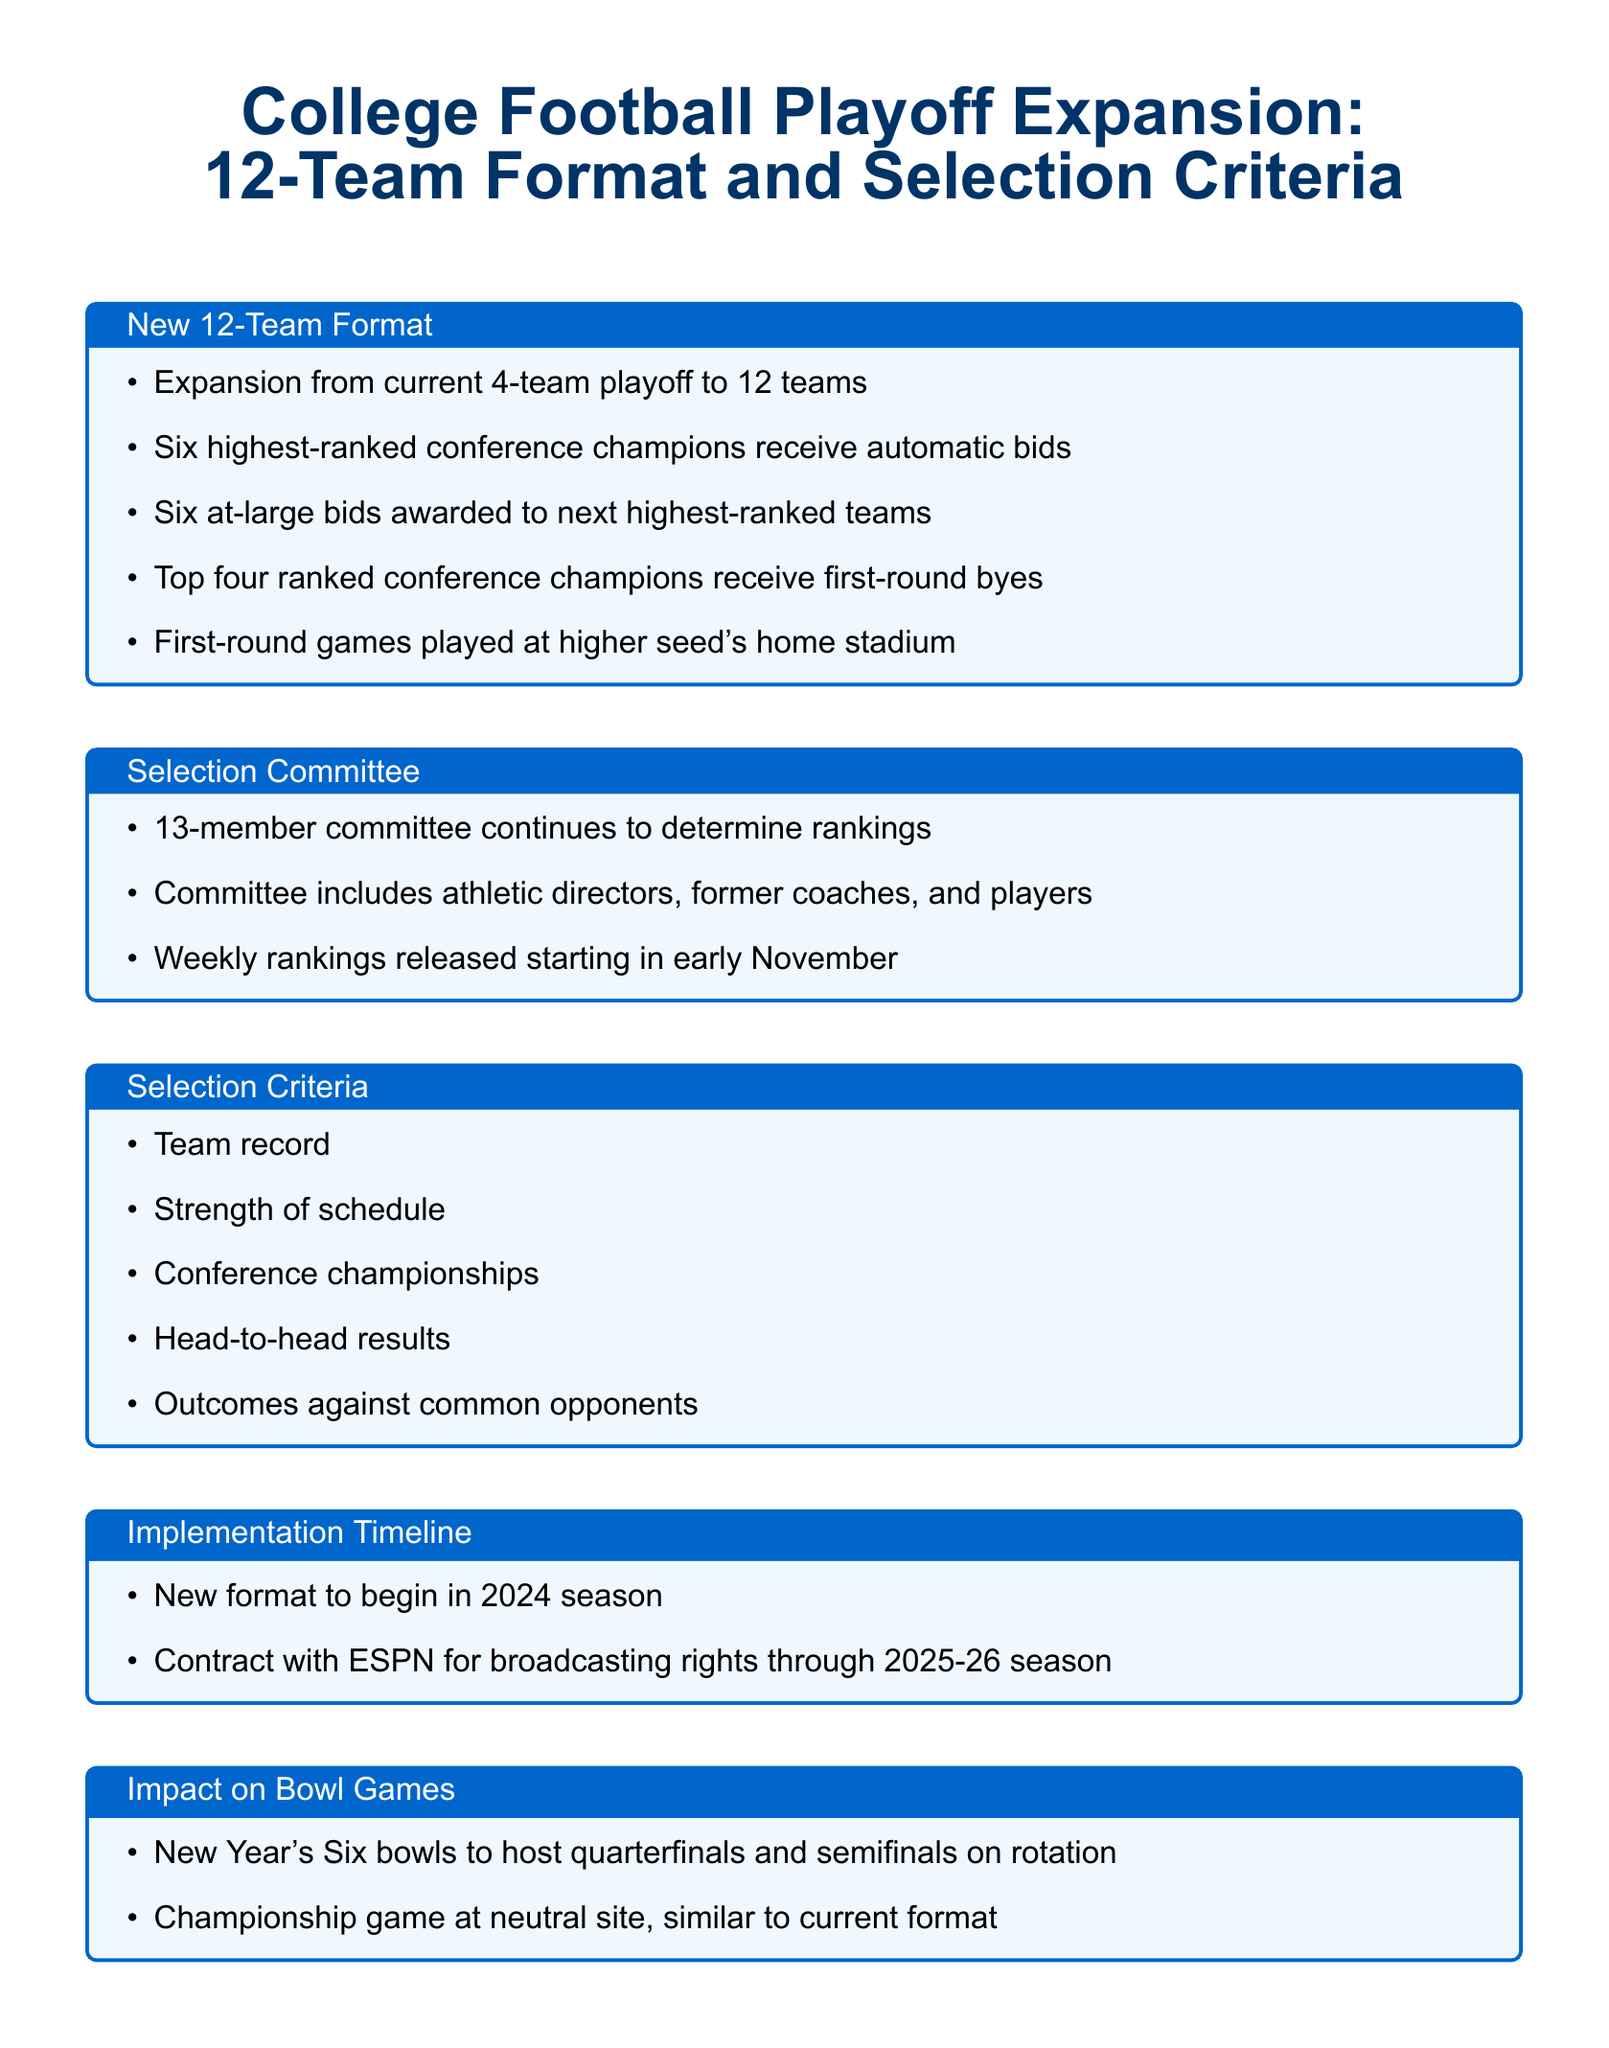What is the new playoff team format? The document states that the playoff will expand from the current 4-team format to a 12-team format.
Answer: 12 teams How many automatic bids do conference champions receive? The document specifies that six highest-ranked conference champions receive automatic bids.
Answer: Six When will the new format begin? The document provides that the new format will begin in the 2024 season.
Answer: 2024 What does the selection committee consist of? According to the document, the committee includes athletic directors, former coaches, and players.
Answer: Athletic directors, former coaches, and players What are the broadcasting rights contract duration through which media source? The document notes a broadcasting rights contract with ESPN through the 2025-26 season.
Answer: ESPN How many at-large bids are available? The document mentions that there will be six at-large bids awarded to the next highest-ranked teams.
Answer: Six What is a criterion considered for team selection? The document lists several criteria, including team record, strength of schedule, and conference championships.
Answer: Team record Where will the first-round games be played? The document explains that first-round games will be played at the higher seed's home stadium.
Answer: Higher seed's home stadium What is the status of the championship game format? The document indicates that the championship game will be held at a neutral site, similar to the current format.
Answer: Neutral site 